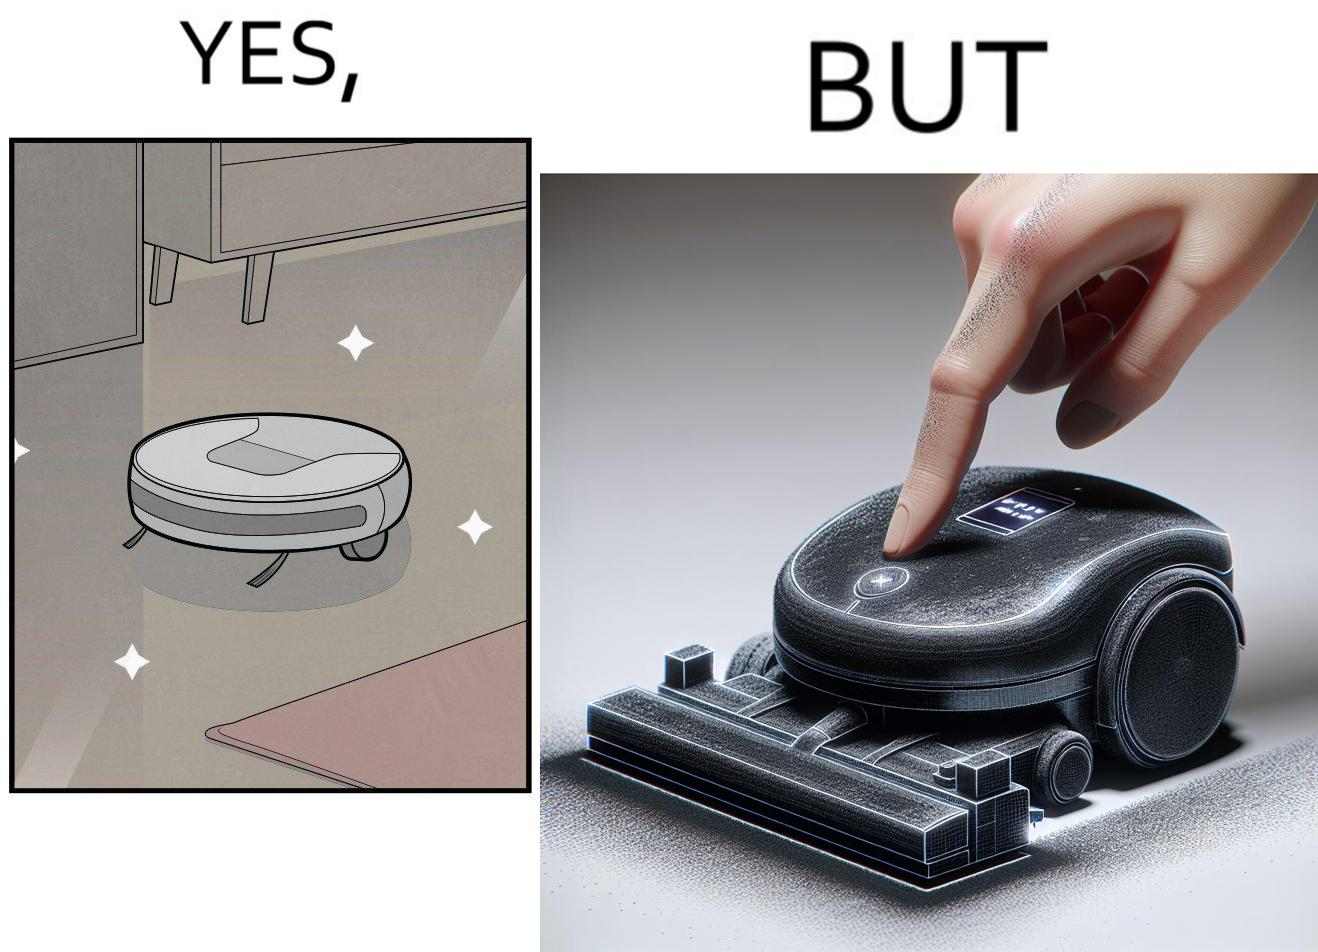Describe what you see in this image. This is funny, because the machine while doing its job cleans everything but ends up being dirty itself. 